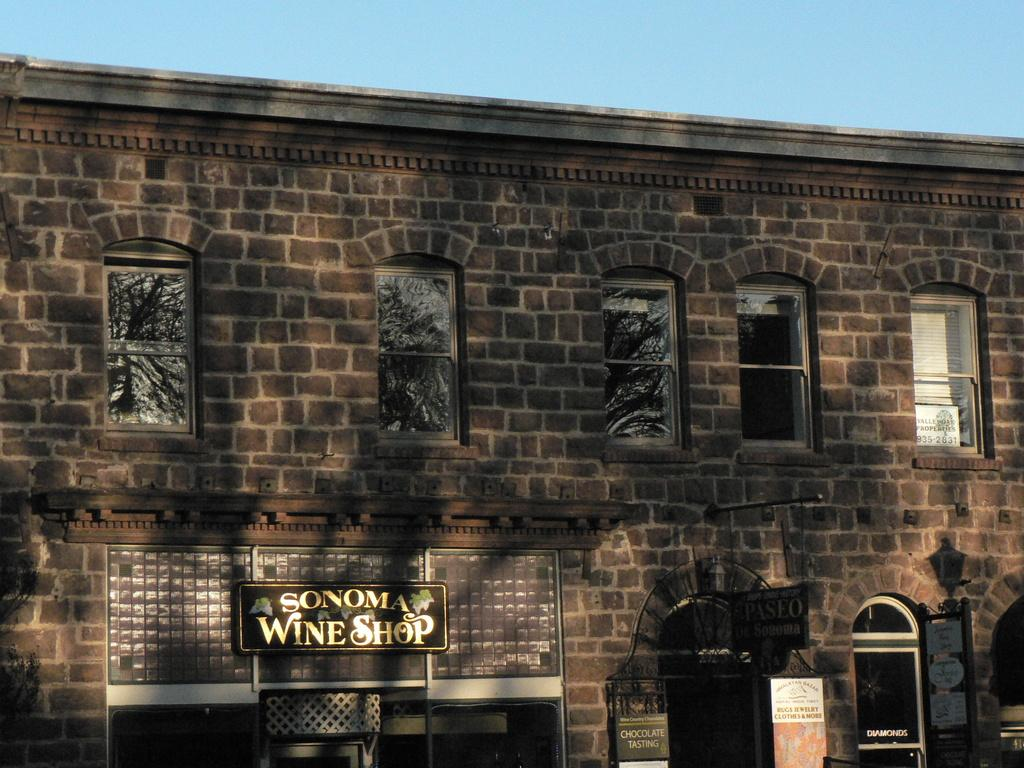<image>
Present a compact description of the photo's key features. the exterior brick facade of Sonoma Wine Shop 